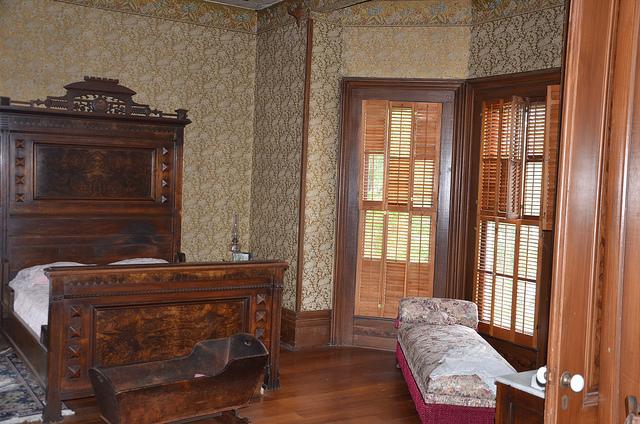What is the main color in the area rug?
Quick response, please. Blue. Is there a sofa in the room?
Concise answer only. No. What object is on the floor, at the foot of the bed?
Quick response, please. Cradle. 